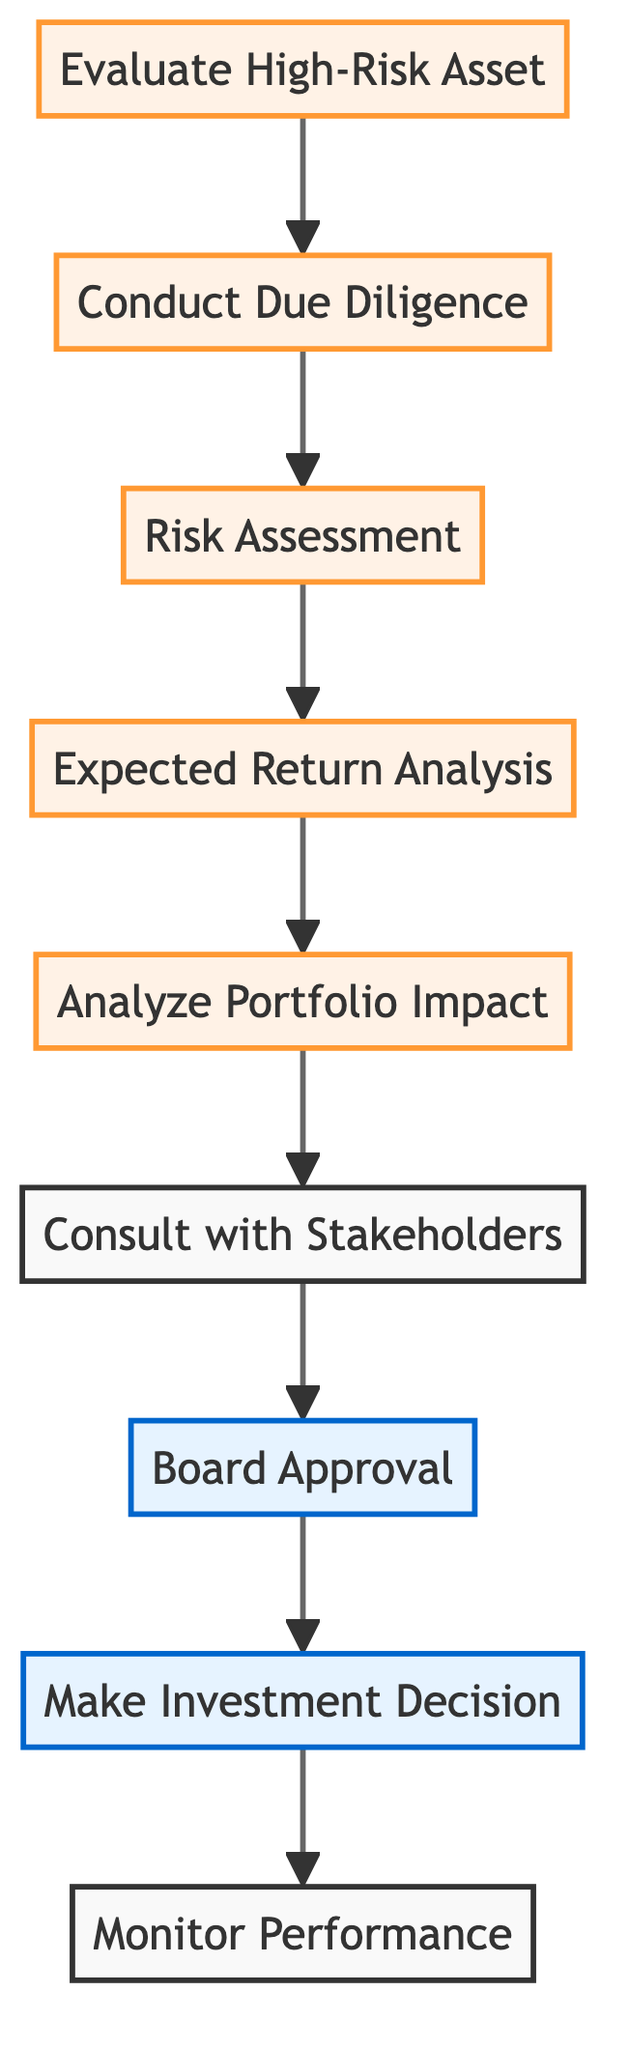What is the starting node of the investment decision flow? The diagram shows "Evaluate High-Risk Asset" as the first node, indicating the starting point of the investment decision process.
Answer: Evaluate High-Risk Asset How many nodes are present in the diagram? By counting each unique node listed in the data, I find that there are eight nodes in total within the diagram.
Answer: 8 What is the final node of the investment decision flow? The last node listed in the edges indicates that "Monitor Performance" is the final step in the investment decision process.
Answer: Monitor Performance Which step follows "Stakeholder Consultation"? The flow from "Stakeholder Consultation" clearly leads to "Board Approval", establishing it as the direct successor in the investment decision process.
Answer: Board Approval What type of node is "Investment Decision"? The node "Investment Decision" is classified as a decision node within the diagram, highlighting its role in making a crucial investment choice.
Answer: decision How many edges connect "Risk Assessment" to other nodes? "Risk Assessment" is connected to one subsequent node, "Expected Return Analysis". This indicates that it only leads to that one specific process in the flow.
Answer: 1 Which node must be completed before "Make Investment Decision"? According to the flow, "Board Approval" must be completed before proceeding to "Make Investment Decision", making it a prerequisite step in the process.
Answer: Board Approval What node precedes "Analyze Portfolio Impact"? Following the directed arrows in the diagram, it is clear that "Expected Return Analysis" directly precedes "Analyze Portfolio Impact".
Answer: Expected Return Analysis What is the total number of edges in this directed graph? By counting the connections (edges) between nodes, I find that there are seven edges total, linking the various steps in the investment decision process.
Answer: 7 